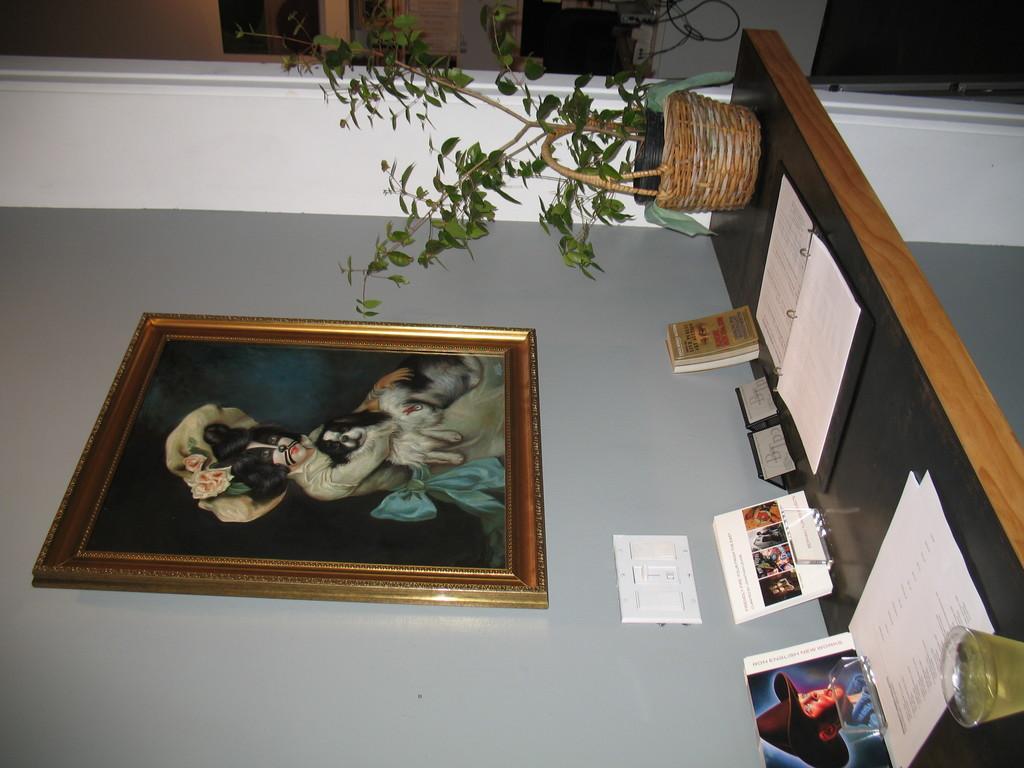Please provide a concise description of this image. This is an inverted image, there is a table on the right side with books,plant pot and glass on it with a painting above it on the wall. 